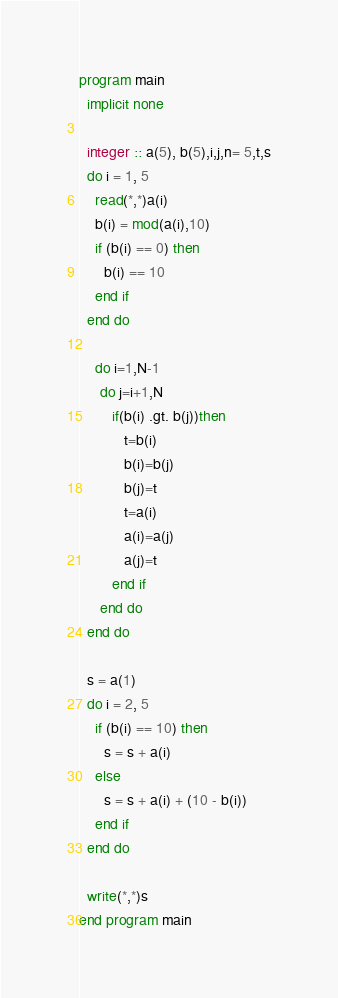Convert code to text. <code><loc_0><loc_0><loc_500><loc_500><_FORTRAN_>program main
  implicit none
  
  integer :: a(5), b(5),i,j,n= 5,t,s
  do i = 1, 5
    read(*,*)a(i)
    b(i) = mod(a(i),10)
    if (b(i) == 0) then
      b(i) == 10
    end if
  end do
  
    do i=1,N-1
     do j=i+1,N
        if(b(i) .gt. b(j))then
           t=b(i)
           b(i)=b(j)
           b(j)=t
           t=a(i)
           a(i)=a(j)
           a(j)=t
        end if
     end do
  end do
  
  s = a(1)
  do i = 2, 5
    if (b(i) == 10) then
      s = s + a(i)
    else
      s = s + a(i) + (10 - b(i))
    end if
  end do
  
  write(*,*)s
end program main</code> 